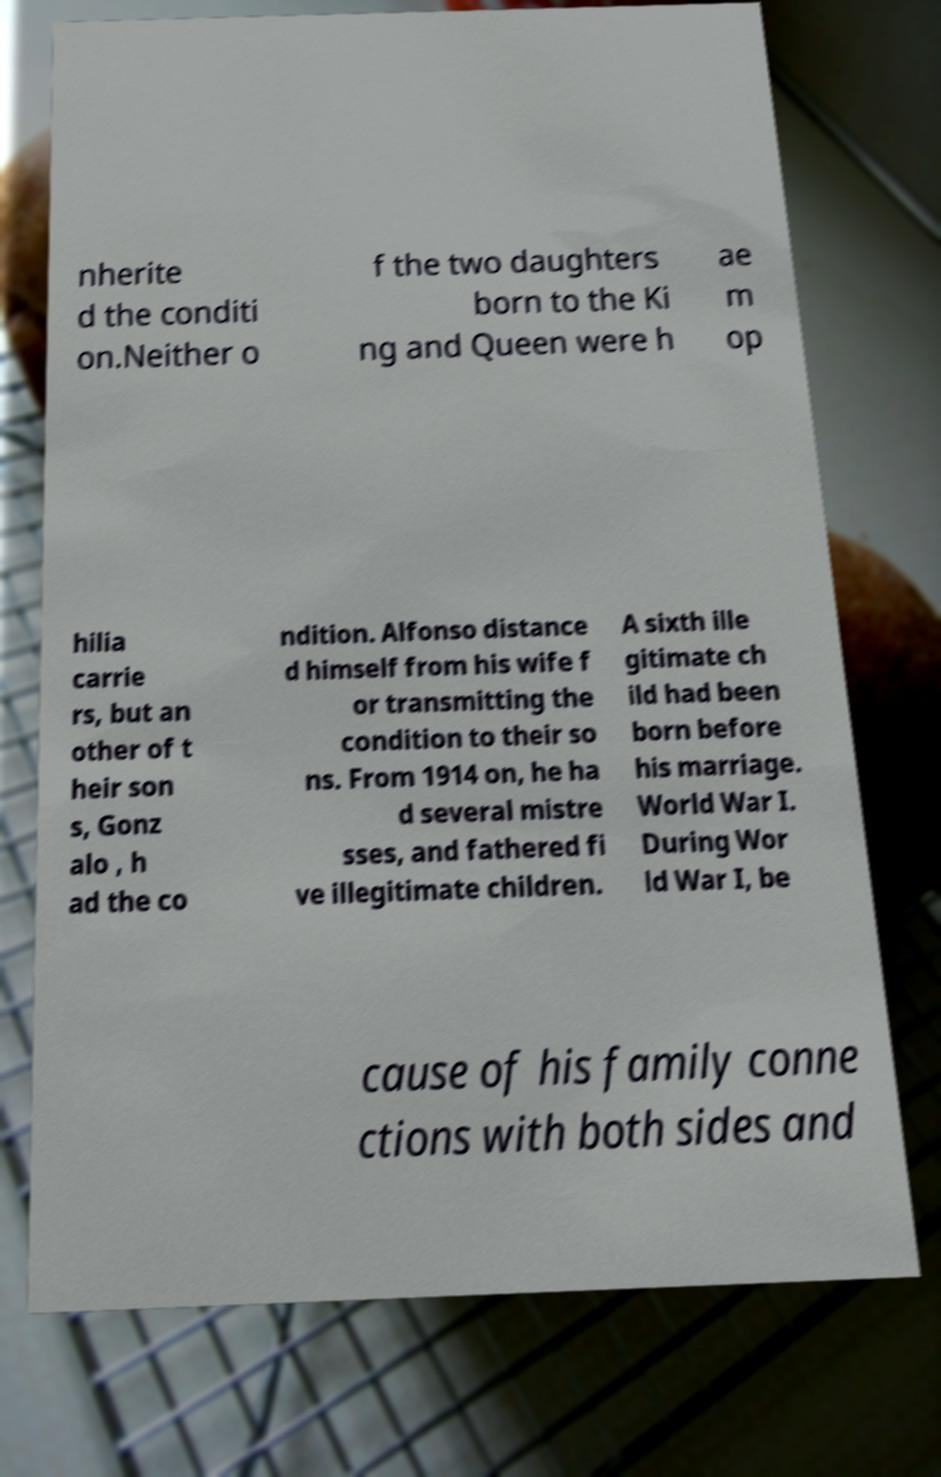What messages or text are displayed in this image? I need them in a readable, typed format. nherite d the conditi on.Neither o f the two daughters born to the Ki ng and Queen were h ae m op hilia carrie rs, but an other of t heir son s, Gonz alo , h ad the co ndition. Alfonso distance d himself from his wife f or transmitting the condition to their so ns. From 1914 on, he ha d several mistre sses, and fathered fi ve illegitimate children. A sixth ille gitimate ch ild had been born before his marriage. World War I. During Wor ld War I, be cause of his family conne ctions with both sides and 